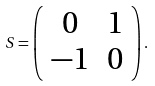<formula> <loc_0><loc_0><loc_500><loc_500>S = \left ( \begin{array} { c c } 0 & 1 \\ - 1 & 0 \end{array} \right ) .</formula> 